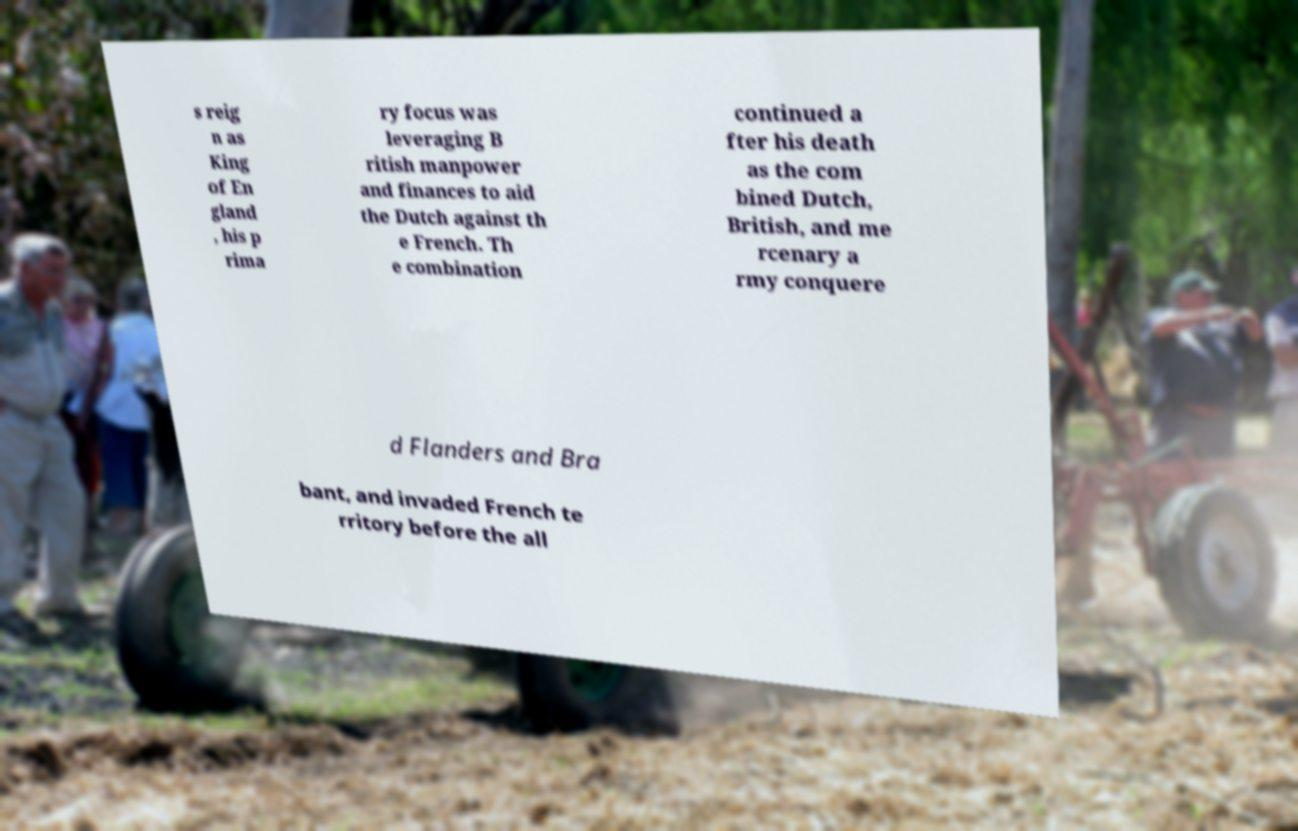Can you read and provide the text displayed in the image?This photo seems to have some interesting text. Can you extract and type it out for me? s reig n as King of En gland , his p rima ry focus was leveraging B ritish manpower and finances to aid the Dutch against th e French. Th e combination continued a fter his death as the com bined Dutch, British, and me rcenary a rmy conquere d Flanders and Bra bant, and invaded French te rritory before the all 